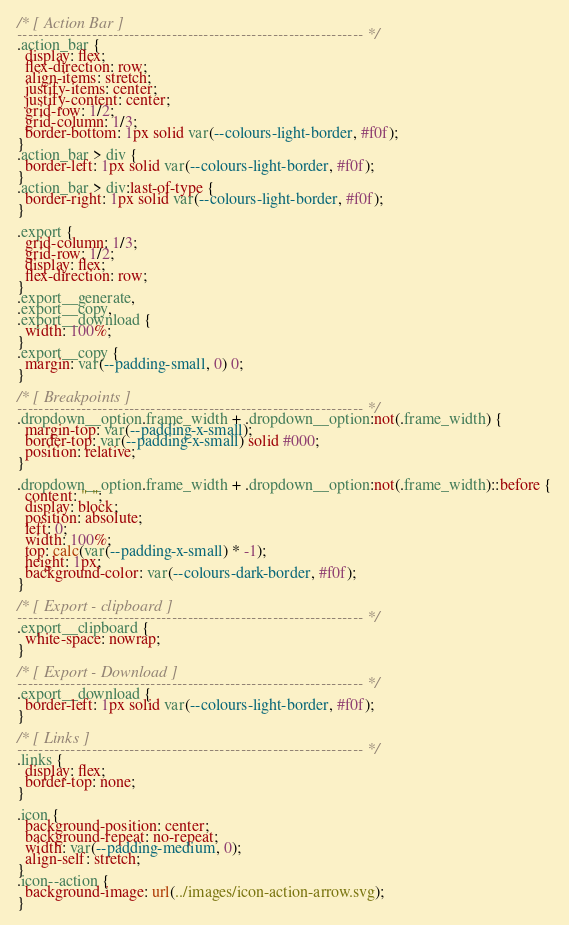<code> <loc_0><loc_0><loc_500><loc_500><_CSS_>/* [ Action Bar ]
----------------------------------------------------------------- */
.action_bar {
  display: flex;
  flex-direction: row;
  align-items: stretch;
  justify-items: center;
  justify-content: center;
  grid-row: 1/2;
  grid-column: 1/3;
  border-bottom: 1px solid var(--colours-light-border, #f0f);
}
.action_bar > div {
  border-left: 1px solid var(--colours-light-border, #f0f);
}
.action_bar > div:last-of-type {
  border-right: 1px solid var(--colours-light-border, #f0f);
}

.export {
  grid-column: 1/3;
  grid-row: 1/2;
  display: flex;
  flex-direction: row;
}
.export__generate,
.export__copy,
.export__download {
  width: 100%;
}
.export__copy {
  margin: var(--padding-small, 0) 0;
}

/* [ Breakpoints ]
----------------------------------------------------------------- */
.dropdown__option.frame_width + .dropdown__option:not(.frame_width) {
  margin-top: var(--padding-x-small);
  border-top: var(--padding-x-small) solid #000;
  position: relative;
}

.dropdown__option.frame_width + .dropdown__option:not(.frame_width)::before {
  content: " ";
  display: block;
  position: absolute;
  left: 0;
  width: 100%;
  top: calc(var(--padding-x-small) * -1);
  height: 1px;
  background-color: var(--colours-dark-border, #f0f);
}

/* [ Export - clipboard ]
----------------------------------------------------------------- */
.export__clipboard {
  white-space: nowrap;
}

/* [ Export - Download ]
----------------------------------------------------------------- */
.export__download {
  border-left: 1px solid var(--colours-light-border, #f0f);
}

/* [ Links ]
----------------------------------------------------------------- */
.links {
  display: flex;
  border-top: none;
}

.icon {
  background-position: center;
  background-repeat: no-repeat;
  width: var(--padding-medium, 0);
  align-self: stretch;
}
.icon--action {
  background-image: url(../images/icon-action-arrow.svg);
}
</code> 